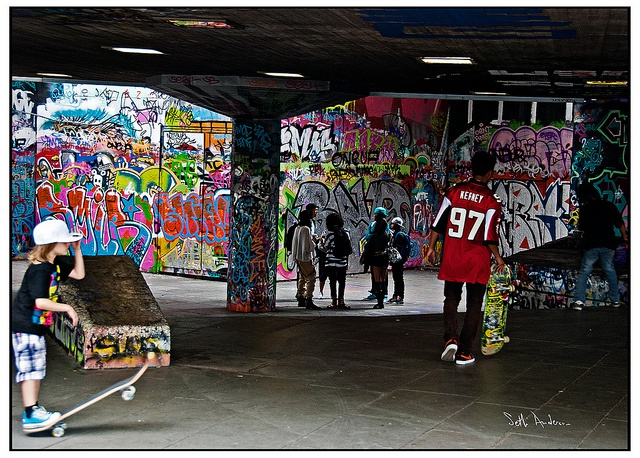Describe the objects in this image and their specific colors. I can see people in white, black, maroon, and lightgray tones, people in white, black, tan, and brown tones, people in white, black, darkblue, teal, and gray tones, people in white, black, gray, darkgray, and lightgray tones, and skateboard in white, black, olive, gray, and darkgreen tones in this image. 